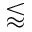Convert formula to latex. <formula><loc_0><loc_0><loc_500><loc_500>\lessapprox</formula> 